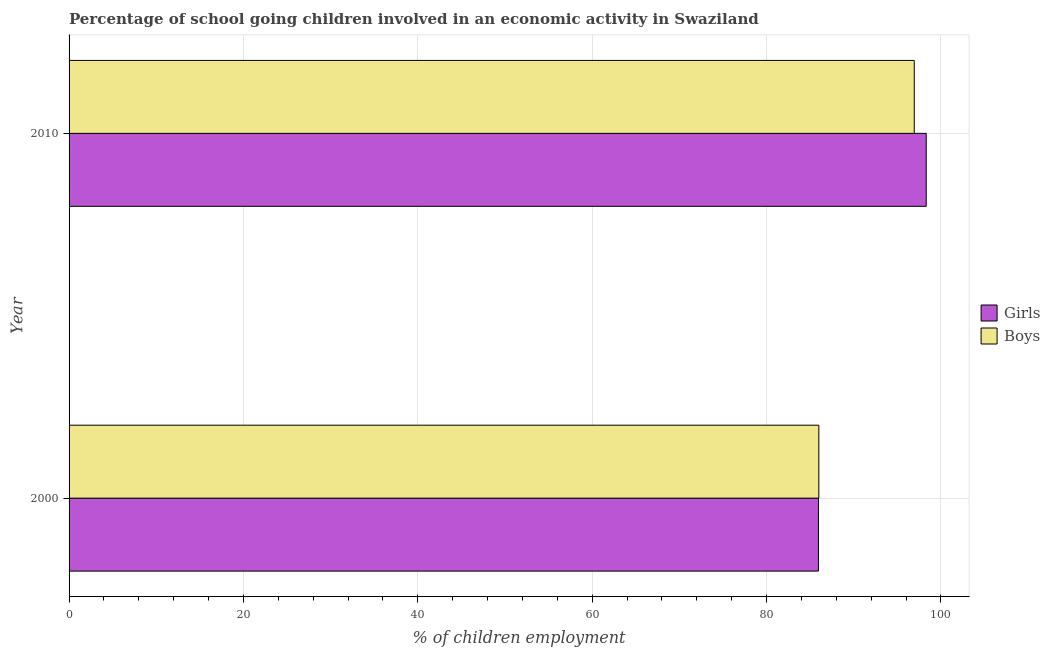How many groups of bars are there?
Your response must be concise. 2. How many bars are there on the 2nd tick from the top?
Provide a short and direct response. 2. In how many cases, is the number of bars for a given year not equal to the number of legend labels?
Your response must be concise. 0. What is the percentage of school going boys in 2000?
Give a very brief answer. 86. Across all years, what is the maximum percentage of school going boys?
Make the answer very short. 96.95. Across all years, what is the minimum percentage of school going girls?
Your response must be concise. 85.96. In which year was the percentage of school going girls maximum?
Give a very brief answer. 2010. What is the total percentage of school going boys in the graph?
Your answer should be very brief. 182.95. What is the difference between the percentage of school going boys in 2000 and that in 2010?
Your response must be concise. -10.95. What is the difference between the percentage of school going girls in 2010 and the percentage of school going boys in 2000?
Give a very brief answer. 12.32. What is the average percentage of school going boys per year?
Offer a terse response. 91.47. In the year 2010, what is the difference between the percentage of school going girls and percentage of school going boys?
Your response must be concise. 1.37. What is the ratio of the percentage of school going boys in 2000 to that in 2010?
Make the answer very short. 0.89. Is the percentage of school going girls in 2000 less than that in 2010?
Offer a terse response. Yes. Is the difference between the percentage of school going girls in 2000 and 2010 greater than the difference between the percentage of school going boys in 2000 and 2010?
Make the answer very short. No. In how many years, is the percentage of school going boys greater than the average percentage of school going boys taken over all years?
Make the answer very short. 1. What does the 2nd bar from the top in 2010 represents?
Give a very brief answer. Girls. What does the 1st bar from the bottom in 2010 represents?
Provide a short and direct response. Girls. How many bars are there?
Offer a very short reply. 4. How many years are there in the graph?
Your answer should be compact. 2. Are the values on the major ticks of X-axis written in scientific E-notation?
Ensure brevity in your answer.  No. Does the graph contain any zero values?
Provide a succinct answer. No. How are the legend labels stacked?
Your response must be concise. Vertical. What is the title of the graph?
Keep it short and to the point. Percentage of school going children involved in an economic activity in Swaziland. What is the label or title of the X-axis?
Your answer should be very brief. % of children employment. What is the % of children employment in Girls in 2000?
Keep it short and to the point. 85.96. What is the % of children employment of Boys in 2000?
Make the answer very short. 86. What is the % of children employment of Girls in 2010?
Offer a terse response. 98.32. What is the % of children employment of Boys in 2010?
Ensure brevity in your answer.  96.95. Across all years, what is the maximum % of children employment of Girls?
Provide a succinct answer. 98.32. Across all years, what is the maximum % of children employment of Boys?
Provide a short and direct response. 96.95. Across all years, what is the minimum % of children employment in Girls?
Offer a terse response. 85.96. Across all years, what is the minimum % of children employment in Boys?
Offer a terse response. 86. What is the total % of children employment in Girls in the graph?
Give a very brief answer. 184.28. What is the total % of children employment in Boys in the graph?
Keep it short and to the point. 182.95. What is the difference between the % of children employment in Girls in 2000 and that in 2010?
Provide a succinct answer. -12.36. What is the difference between the % of children employment of Boys in 2000 and that in 2010?
Ensure brevity in your answer.  -10.95. What is the difference between the % of children employment of Girls in 2000 and the % of children employment of Boys in 2010?
Offer a terse response. -10.99. What is the average % of children employment of Girls per year?
Make the answer very short. 92.14. What is the average % of children employment in Boys per year?
Provide a short and direct response. 91.47. In the year 2000, what is the difference between the % of children employment of Girls and % of children employment of Boys?
Your response must be concise. -0.04. In the year 2010, what is the difference between the % of children employment in Girls and % of children employment in Boys?
Your answer should be compact. 1.37. What is the ratio of the % of children employment in Girls in 2000 to that in 2010?
Offer a very short reply. 0.87. What is the ratio of the % of children employment of Boys in 2000 to that in 2010?
Make the answer very short. 0.89. What is the difference between the highest and the second highest % of children employment of Girls?
Offer a very short reply. 12.36. What is the difference between the highest and the second highest % of children employment of Boys?
Provide a succinct answer. 10.95. What is the difference between the highest and the lowest % of children employment in Girls?
Your answer should be very brief. 12.36. What is the difference between the highest and the lowest % of children employment in Boys?
Keep it short and to the point. 10.95. 